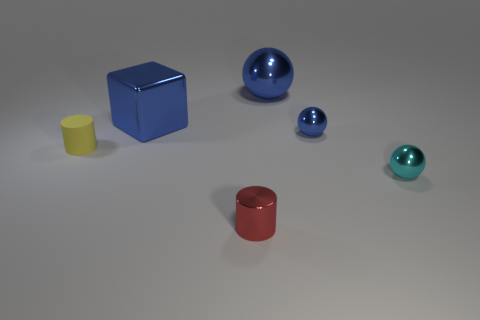Is there anything else that has the same material as the tiny yellow thing?
Provide a succinct answer. No. How many things are tiny balls that are behind the tiny red metallic cylinder or blue things on the left side of the small shiny cylinder?
Your answer should be compact. 3. There is a small object behind the small yellow cylinder; is it the same color as the large sphere?
Give a very brief answer. Yes. How many other objects are there of the same color as the rubber cylinder?
Ensure brevity in your answer.  0. What is the cyan thing made of?
Ensure brevity in your answer.  Metal. There is a object that is in front of the cyan shiny thing; is it the same size as the cyan sphere?
Offer a very short reply. Yes. The other red object that is the same shape as the small matte object is what size?
Offer a very short reply. Small. Are there the same number of small blue things on the left side of the tiny blue metallic ball and small yellow cylinders in front of the tiny red cylinder?
Your answer should be compact. Yes. There is a cyan metallic sphere in front of the metal block; what size is it?
Offer a terse response. Small. Is the color of the cube the same as the large metal sphere?
Keep it short and to the point. Yes. 